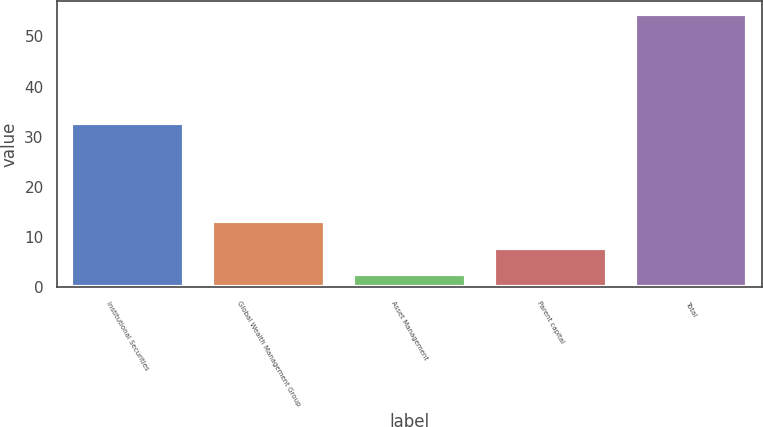Convert chart. <chart><loc_0><loc_0><loc_500><loc_500><bar_chart><fcel>Institutional Securities<fcel>Global Wealth Management Group<fcel>Asset Management<fcel>Parent capital<fcel>Total<nl><fcel>32.7<fcel>13.2<fcel>2.6<fcel>7.78<fcel>54.4<nl></chart> 